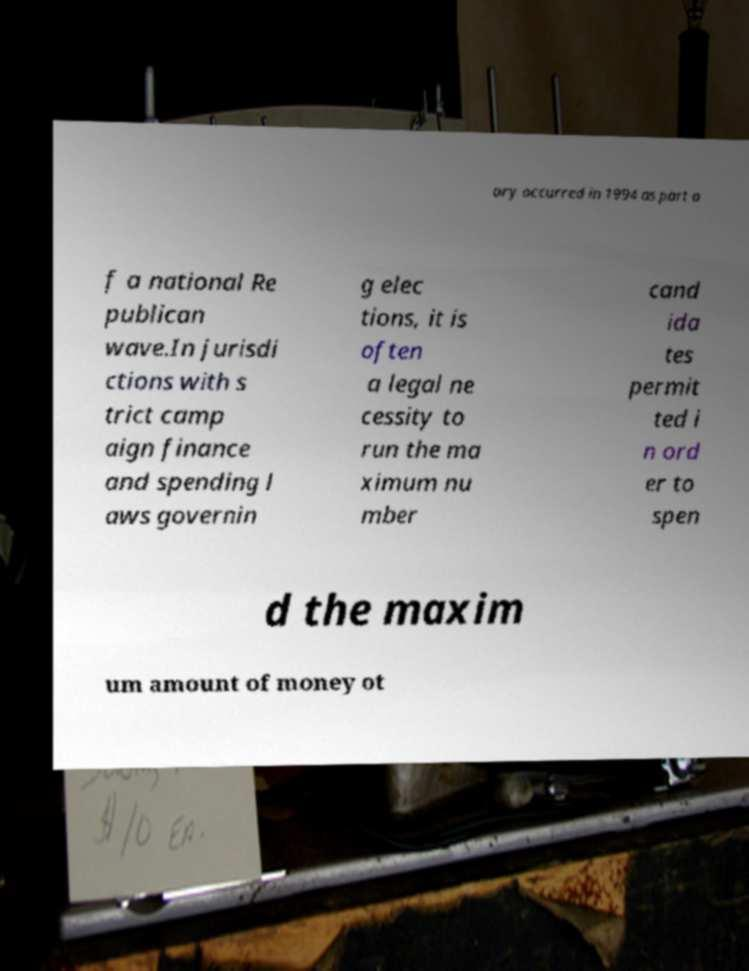Can you read and provide the text displayed in the image?This photo seems to have some interesting text. Can you extract and type it out for me? ory occurred in 1994 as part o f a national Re publican wave.In jurisdi ctions with s trict camp aign finance and spending l aws governin g elec tions, it is often a legal ne cessity to run the ma ximum nu mber cand ida tes permit ted i n ord er to spen d the maxim um amount of money ot 